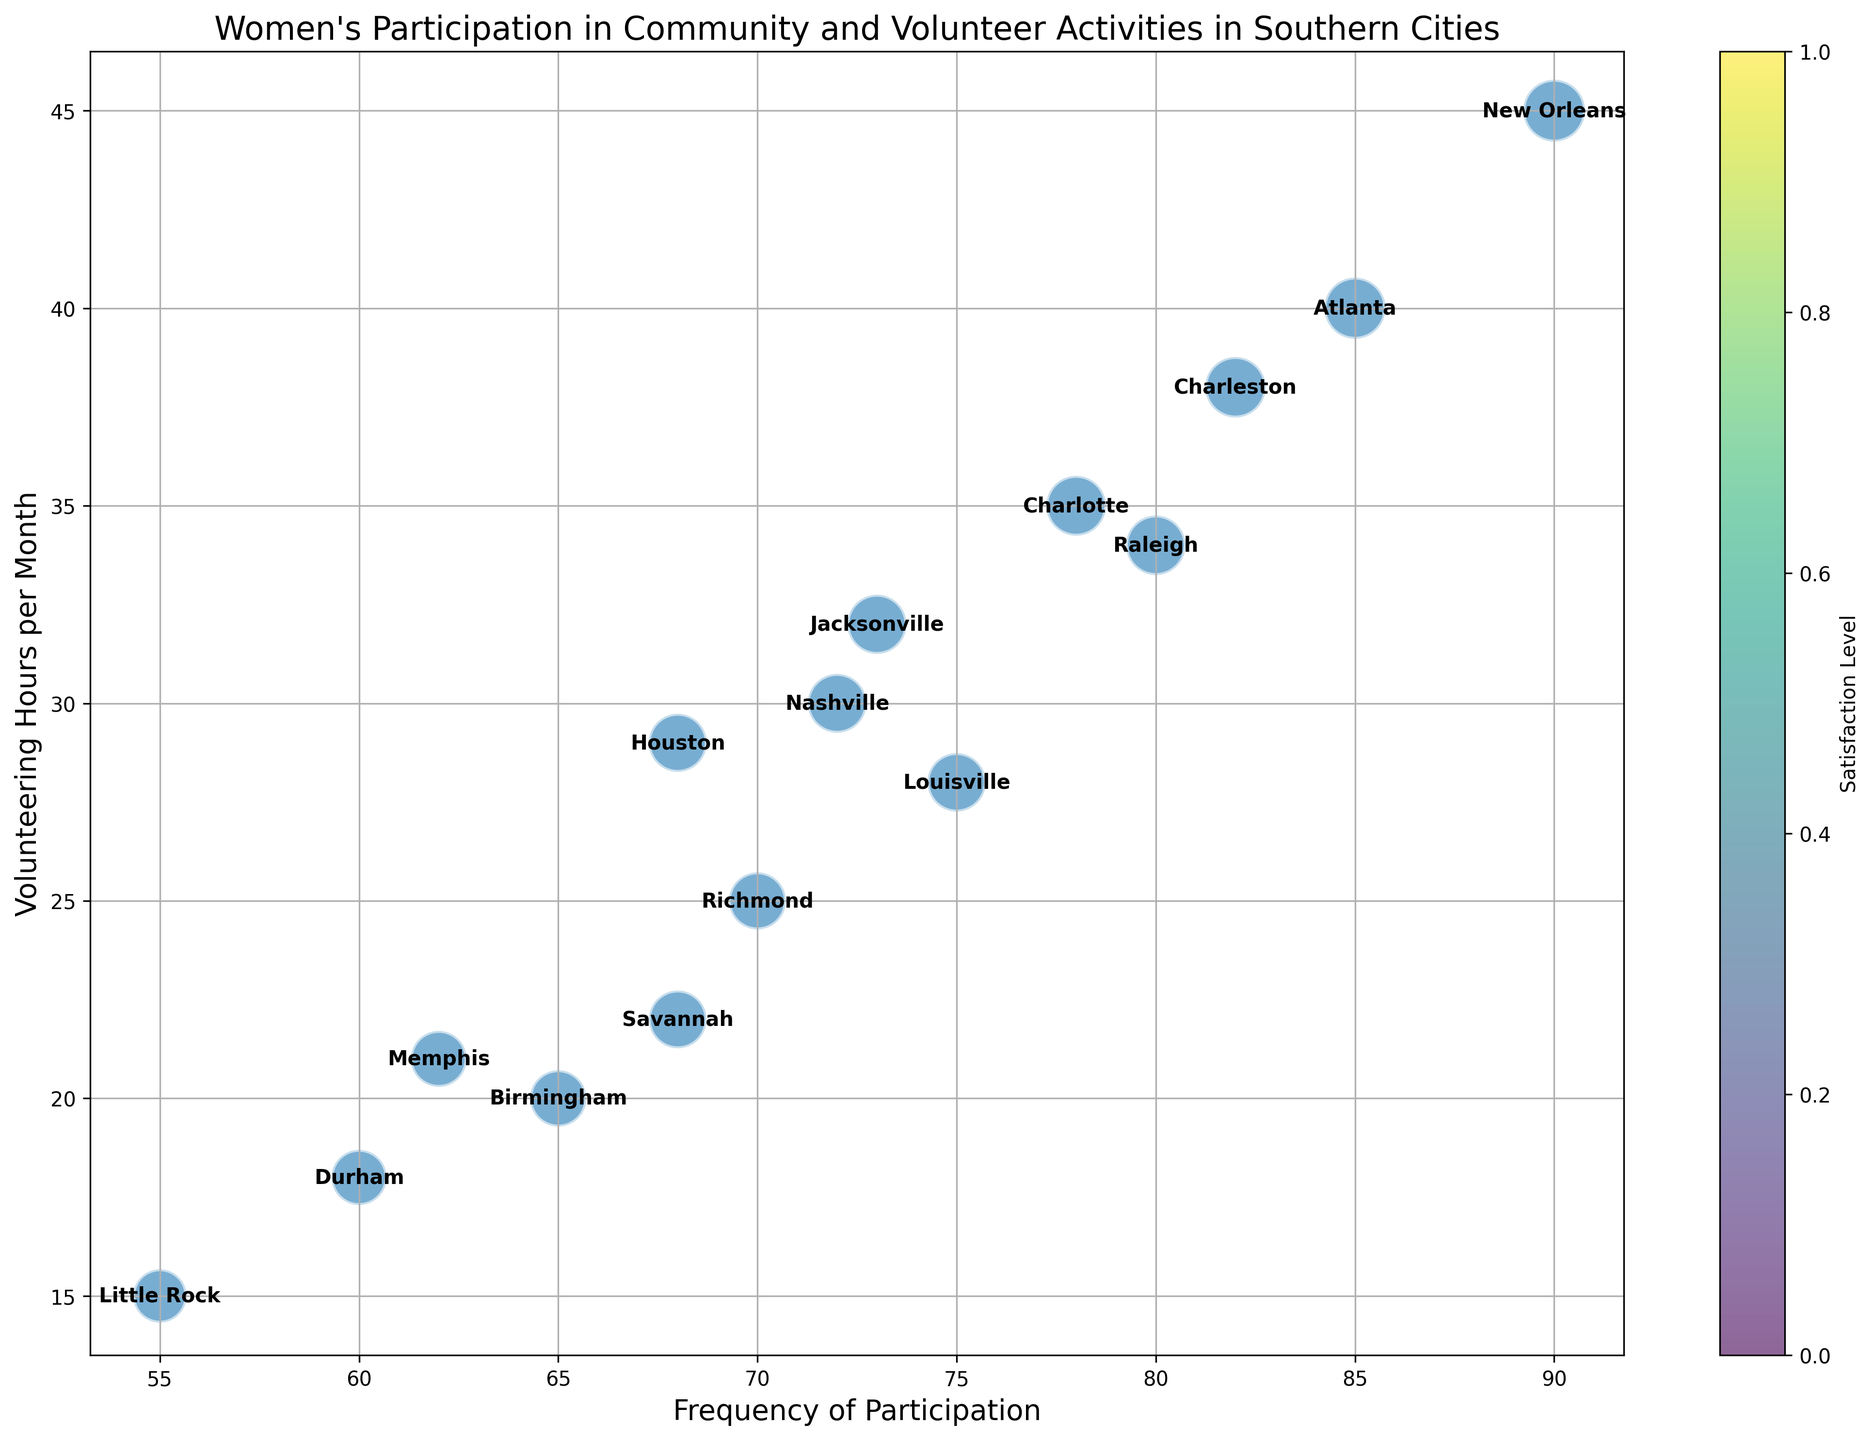Which city has the highest frequency of participation? Looking at the x-axis (Frequency of Participation), the data point with the highest frequency is for New Orleans, which is at 90.
Answer: New Orleans Which city has the smallest bubble size? The bubble size represents the satisfaction level. The smallest bubble corresponds to Little Rock, with a satisfaction level of 70.
Answer: Little Rock What are the average hours of volunteering for the cities with a frequency of 75 or more? Identify the cities with a frequency of 75 or more: Atlanta (40 hours), Charlotte (35), Charleston (38), New Orleans (45), Savannah (22), Louisville (28), Jacksonville (32), Raleigh (34), and Memphis (21). Sum these hours: 40 + 35 + 38 + 45 + 22 + 28 + 32 + 34 + 21 = 295. The number of cities is 9, so average is 295 / 9.
Answer: 32.78 hours Which city among New Orleans, Charleston, and Atlanta has the highest satisfaction level? Referring to the bubble size (satisfaction level), compare New Orleans (94), Charleston (90), and Atlanta (92). New Orleans has the highest satisfaction level.
Answer: New Orleans Do cities with higher participation frequency generally have higher satisfaction levels? By observing the plot, it appears that cities with higher frequencies of participation like New Orleans, Atlanta, and Charleston generally have larger bubbles, indicating higher satisfaction levels.
Answer: Yes Which city spends the least amount of time volunteering per month? Looking at the y-axis (Volunteering Hours per Month), the city with the lowest hours is Little Rock, with 15 hours.
Answer: Little Rock How does the participation frequency of Nashville compare with Memphis? Nashville has a frequency of 72, and Memphis has a frequency of 62. Comparing these, Nashville has a higher frequency than Memphis.
Answer: Nashville has a higher frequency What is the combined satisfaction level of cities whose participation frequencies are below 70? Identify the cities with frequencies below 70: Birmingham (78), Durham (75), Little Rock (70), and Memphis (77). Sum their satisfaction levels: 78 + 75 + 70 + 77 = 300.
Answer: 300 Does Savannah hold a higher frequency of participation than Houston but lower volunteering hours? Savannah has a frequency of 68 and volunteering hours of 22. Houston has a frequency of 68 and volunteering hours of 29. Their frequencies are equal, and Savannah has lower volunteering hours.
Answer: Equal frequency, lower hours By observing the plot, which city among Birmingham, Memphis, and Louisville has the smallest satisfaction level? The bubble sizes for Birmingham (78), Memphis (77), and Louisville (84) show that Memphis has the smallest bubble, indicating the smallest satisfaction level.
Answer: Memphis 